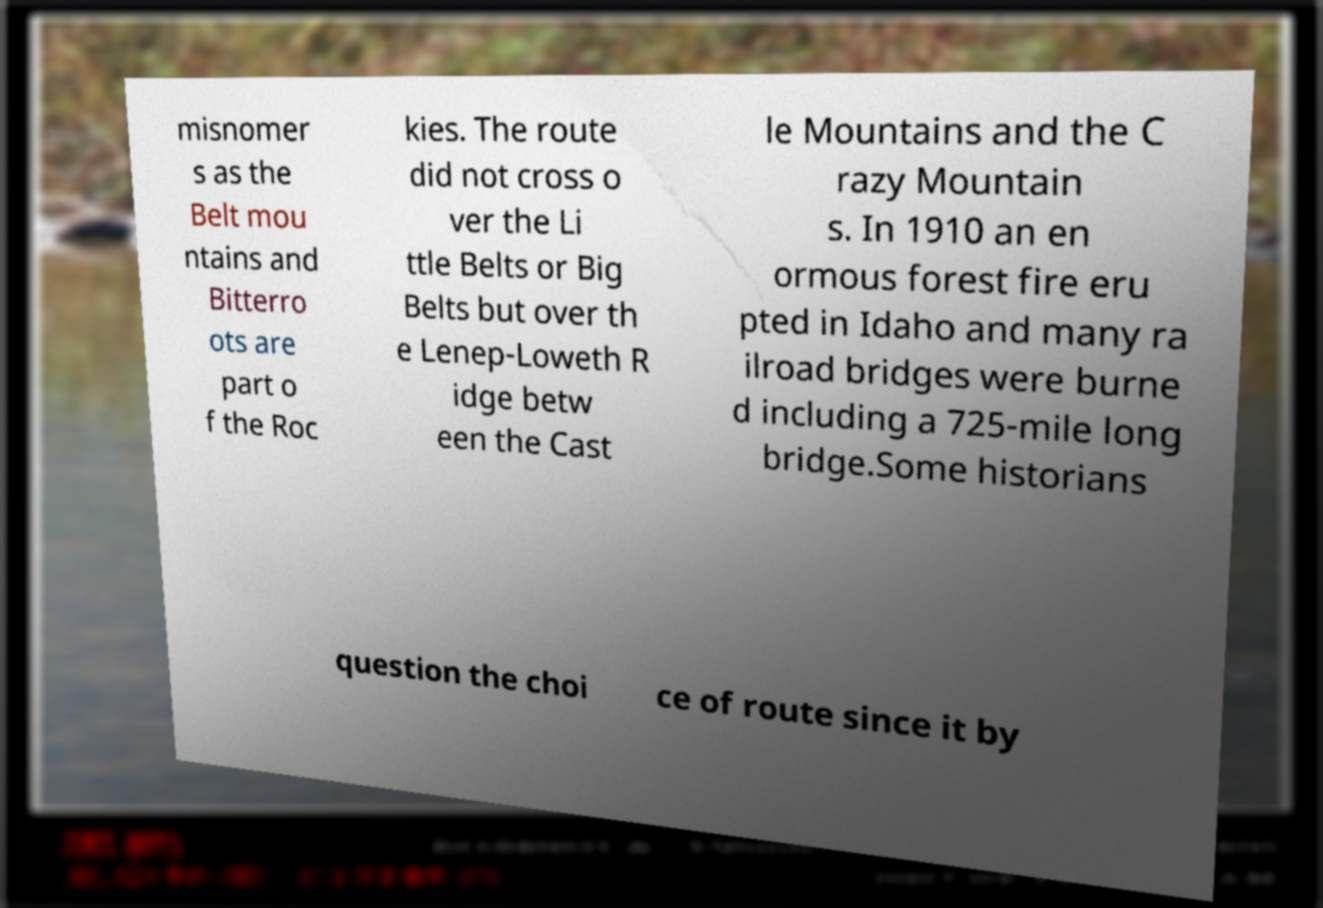For documentation purposes, I need the text within this image transcribed. Could you provide that? misnomer s as the Belt mou ntains and Bitterro ots are part o f the Roc kies. The route did not cross o ver the Li ttle Belts or Big Belts but over th e Lenep-Loweth R idge betw een the Cast le Mountains and the C razy Mountain s. In 1910 an en ormous forest fire eru pted in Idaho and many ra ilroad bridges were burne d including a 725-mile long bridge.Some historians question the choi ce of route since it by 